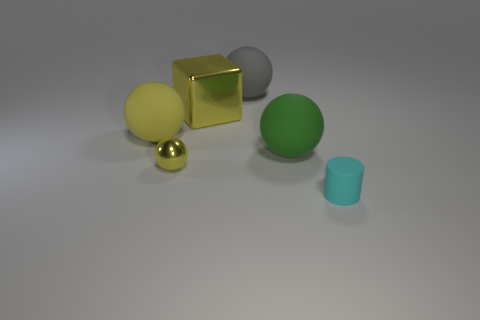Add 3 yellow metallic objects. How many objects exist? 9 Subtract all spheres. How many objects are left? 2 Add 1 tiny yellow rubber cubes. How many tiny yellow rubber cubes exist? 1 Subtract 0 red balls. How many objects are left? 6 Subtract all large things. Subtract all green things. How many objects are left? 1 Add 4 large yellow rubber balls. How many large yellow rubber balls are left? 5 